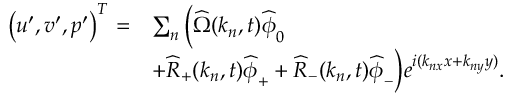<formula> <loc_0><loc_0><loc_500><loc_500>\begin{array} { r l } { \left ( u ^ { \prime } , v ^ { \prime } , p ^ { \prime } \right ) ^ { T } = } & { \sum _ { n } \left ( \widehat { \Omega } ( k _ { n } , t ) \widehat { \phi } _ { 0 } } \\ & { + \widehat { R } _ { + } ( k _ { n } , t ) \widehat { \phi } _ { + } + \widehat { R } _ { - } ( k _ { n } , t ) \widehat { \phi } _ { - } \right ) e ^ { i ( k _ { n x } x + k _ { n y } y ) } . } \end{array}</formula> 